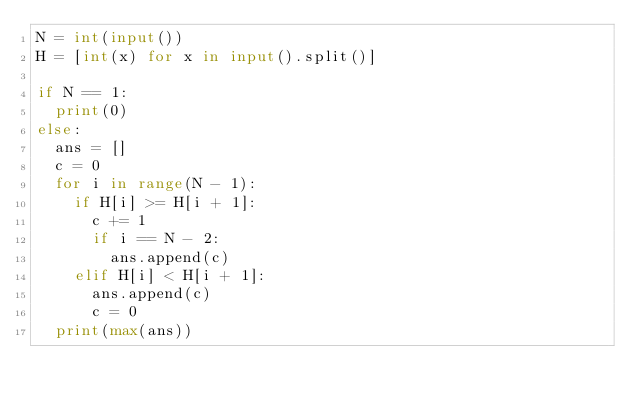<code> <loc_0><loc_0><loc_500><loc_500><_Python_>N = int(input())
H = [int(x) for x in input().split()]

if N == 1:
  print(0)
else:
  ans = []
  c = 0
  for i in range(N - 1):
    if H[i] >= H[i + 1]:
      c += 1
      if i == N - 2:
        ans.append(c)
    elif H[i] < H[i + 1]:
      ans.append(c)
      c = 0
  print(max(ans))</code> 